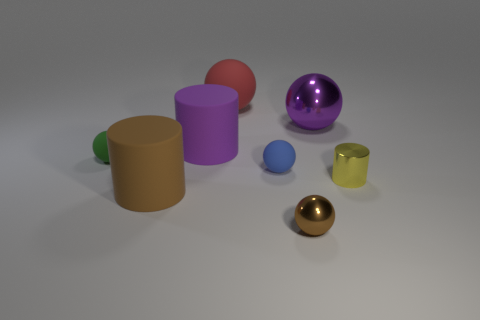Subtract all large rubber balls. How many balls are left? 4 Subtract all red spheres. How many spheres are left? 4 Subtract all yellow spheres. Subtract all yellow cubes. How many spheres are left? 5 Add 1 tiny gray matte objects. How many objects exist? 9 Subtract all cylinders. How many objects are left? 5 Subtract 1 purple cylinders. How many objects are left? 7 Subtract all big purple metal spheres. Subtract all big blue rubber cubes. How many objects are left? 7 Add 3 yellow shiny objects. How many yellow shiny objects are left? 4 Add 4 big gray rubber cylinders. How many big gray rubber cylinders exist? 4 